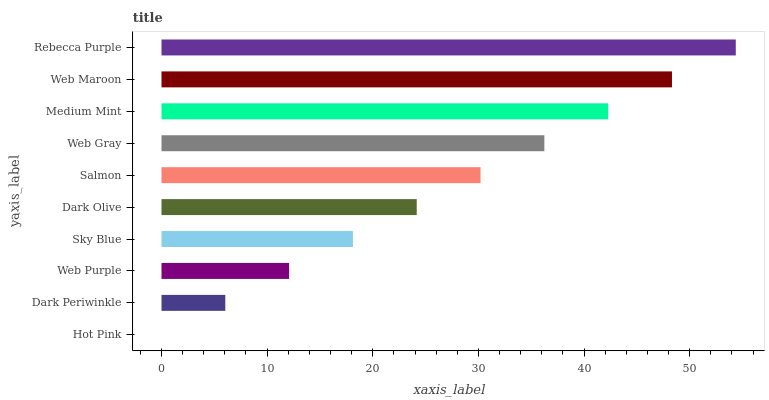Is Hot Pink the minimum?
Answer yes or no. Yes. Is Rebecca Purple the maximum?
Answer yes or no. Yes. Is Dark Periwinkle the minimum?
Answer yes or no. No. Is Dark Periwinkle the maximum?
Answer yes or no. No. Is Dark Periwinkle greater than Hot Pink?
Answer yes or no. Yes. Is Hot Pink less than Dark Periwinkle?
Answer yes or no. Yes. Is Hot Pink greater than Dark Periwinkle?
Answer yes or no. No. Is Dark Periwinkle less than Hot Pink?
Answer yes or no. No. Is Salmon the high median?
Answer yes or no. Yes. Is Dark Olive the low median?
Answer yes or no. Yes. Is Web Purple the high median?
Answer yes or no. No. Is Salmon the low median?
Answer yes or no. No. 